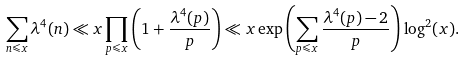Convert formula to latex. <formula><loc_0><loc_0><loc_500><loc_500>\sum _ { n \leqslant x } \lambda ^ { 4 } ( n ) \ll x \prod _ { p \leqslant x } \left ( 1 + \frac { \lambda ^ { 4 } ( p ) } { p } \right ) \ll x \exp \left ( \sum _ { p \leqslant x } \frac { \lambda ^ { 4 } ( p ) - 2 } { p } \right ) \log ^ { 2 } ( x ) .</formula> 